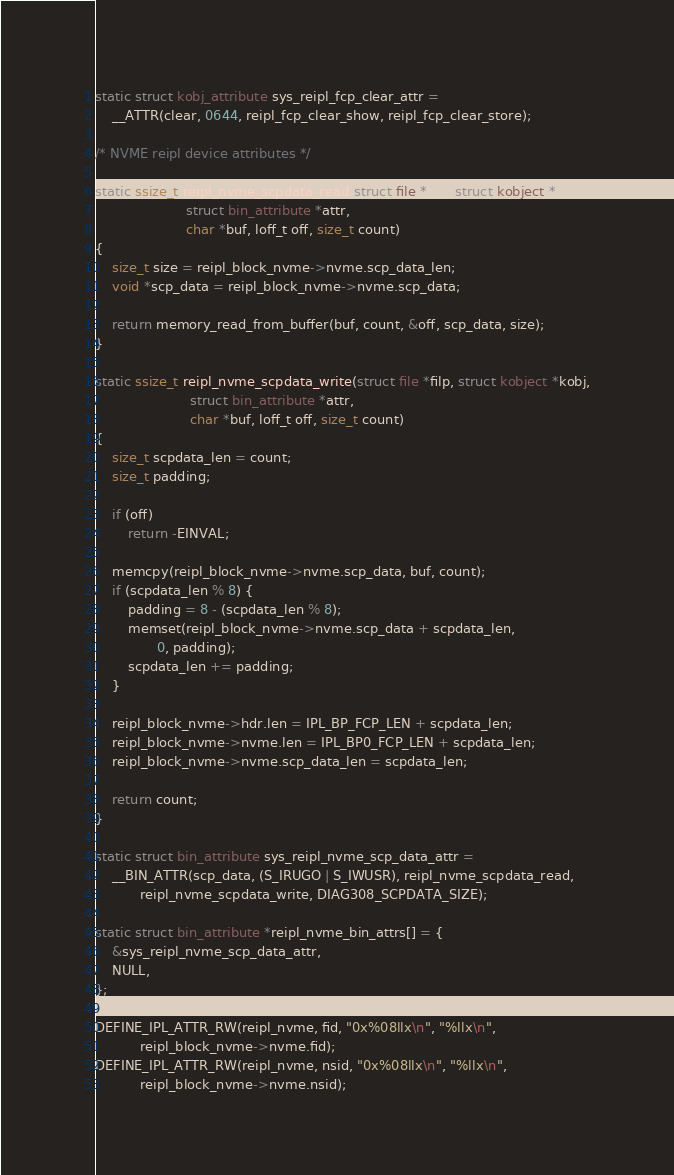Convert code to text. <code><loc_0><loc_0><loc_500><loc_500><_C_>
static struct kobj_attribute sys_reipl_fcp_clear_attr =
	__ATTR(clear, 0644, reipl_fcp_clear_show, reipl_fcp_clear_store);

/* NVME reipl device attributes */

static ssize_t reipl_nvme_scpdata_read(struct file *filp, struct kobject *kobj,
				      struct bin_attribute *attr,
				      char *buf, loff_t off, size_t count)
{
	size_t size = reipl_block_nvme->nvme.scp_data_len;
	void *scp_data = reipl_block_nvme->nvme.scp_data;

	return memory_read_from_buffer(buf, count, &off, scp_data, size);
}

static ssize_t reipl_nvme_scpdata_write(struct file *filp, struct kobject *kobj,
				       struct bin_attribute *attr,
				       char *buf, loff_t off, size_t count)
{
	size_t scpdata_len = count;
	size_t padding;

	if (off)
		return -EINVAL;

	memcpy(reipl_block_nvme->nvme.scp_data, buf, count);
	if (scpdata_len % 8) {
		padding = 8 - (scpdata_len % 8);
		memset(reipl_block_nvme->nvme.scp_data + scpdata_len,
		       0, padding);
		scpdata_len += padding;
	}

	reipl_block_nvme->hdr.len = IPL_BP_FCP_LEN + scpdata_len;
	reipl_block_nvme->nvme.len = IPL_BP0_FCP_LEN + scpdata_len;
	reipl_block_nvme->nvme.scp_data_len = scpdata_len;

	return count;
}

static struct bin_attribute sys_reipl_nvme_scp_data_attr =
	__BIN_ATTR(scp_data, (S_IRUGO | S_IWUSR), reipl_nvme_scpdata_read,
		   reipl_nvme_scpdata_write, DIAG308_SCPDATA_SIZE);

static struct bin_attribute *reipl_nvme_bin_attrs[] = {
	&sys_reipl_nvme_scp_data_attr,
	NULL,
};

DEFINE_IPL_ATTR_RW(reipl_nvme, fid, "0x%08llx\n", "%llx\n",
		   reipl_block_nvme->nvme.fid);
DEFINE_IPL_ATTR_RW(reipl_nvme, nsid, "0x%08llx\n", "%llx\n",
		   reipl_block_nvme->nvme.nsid);</code> 